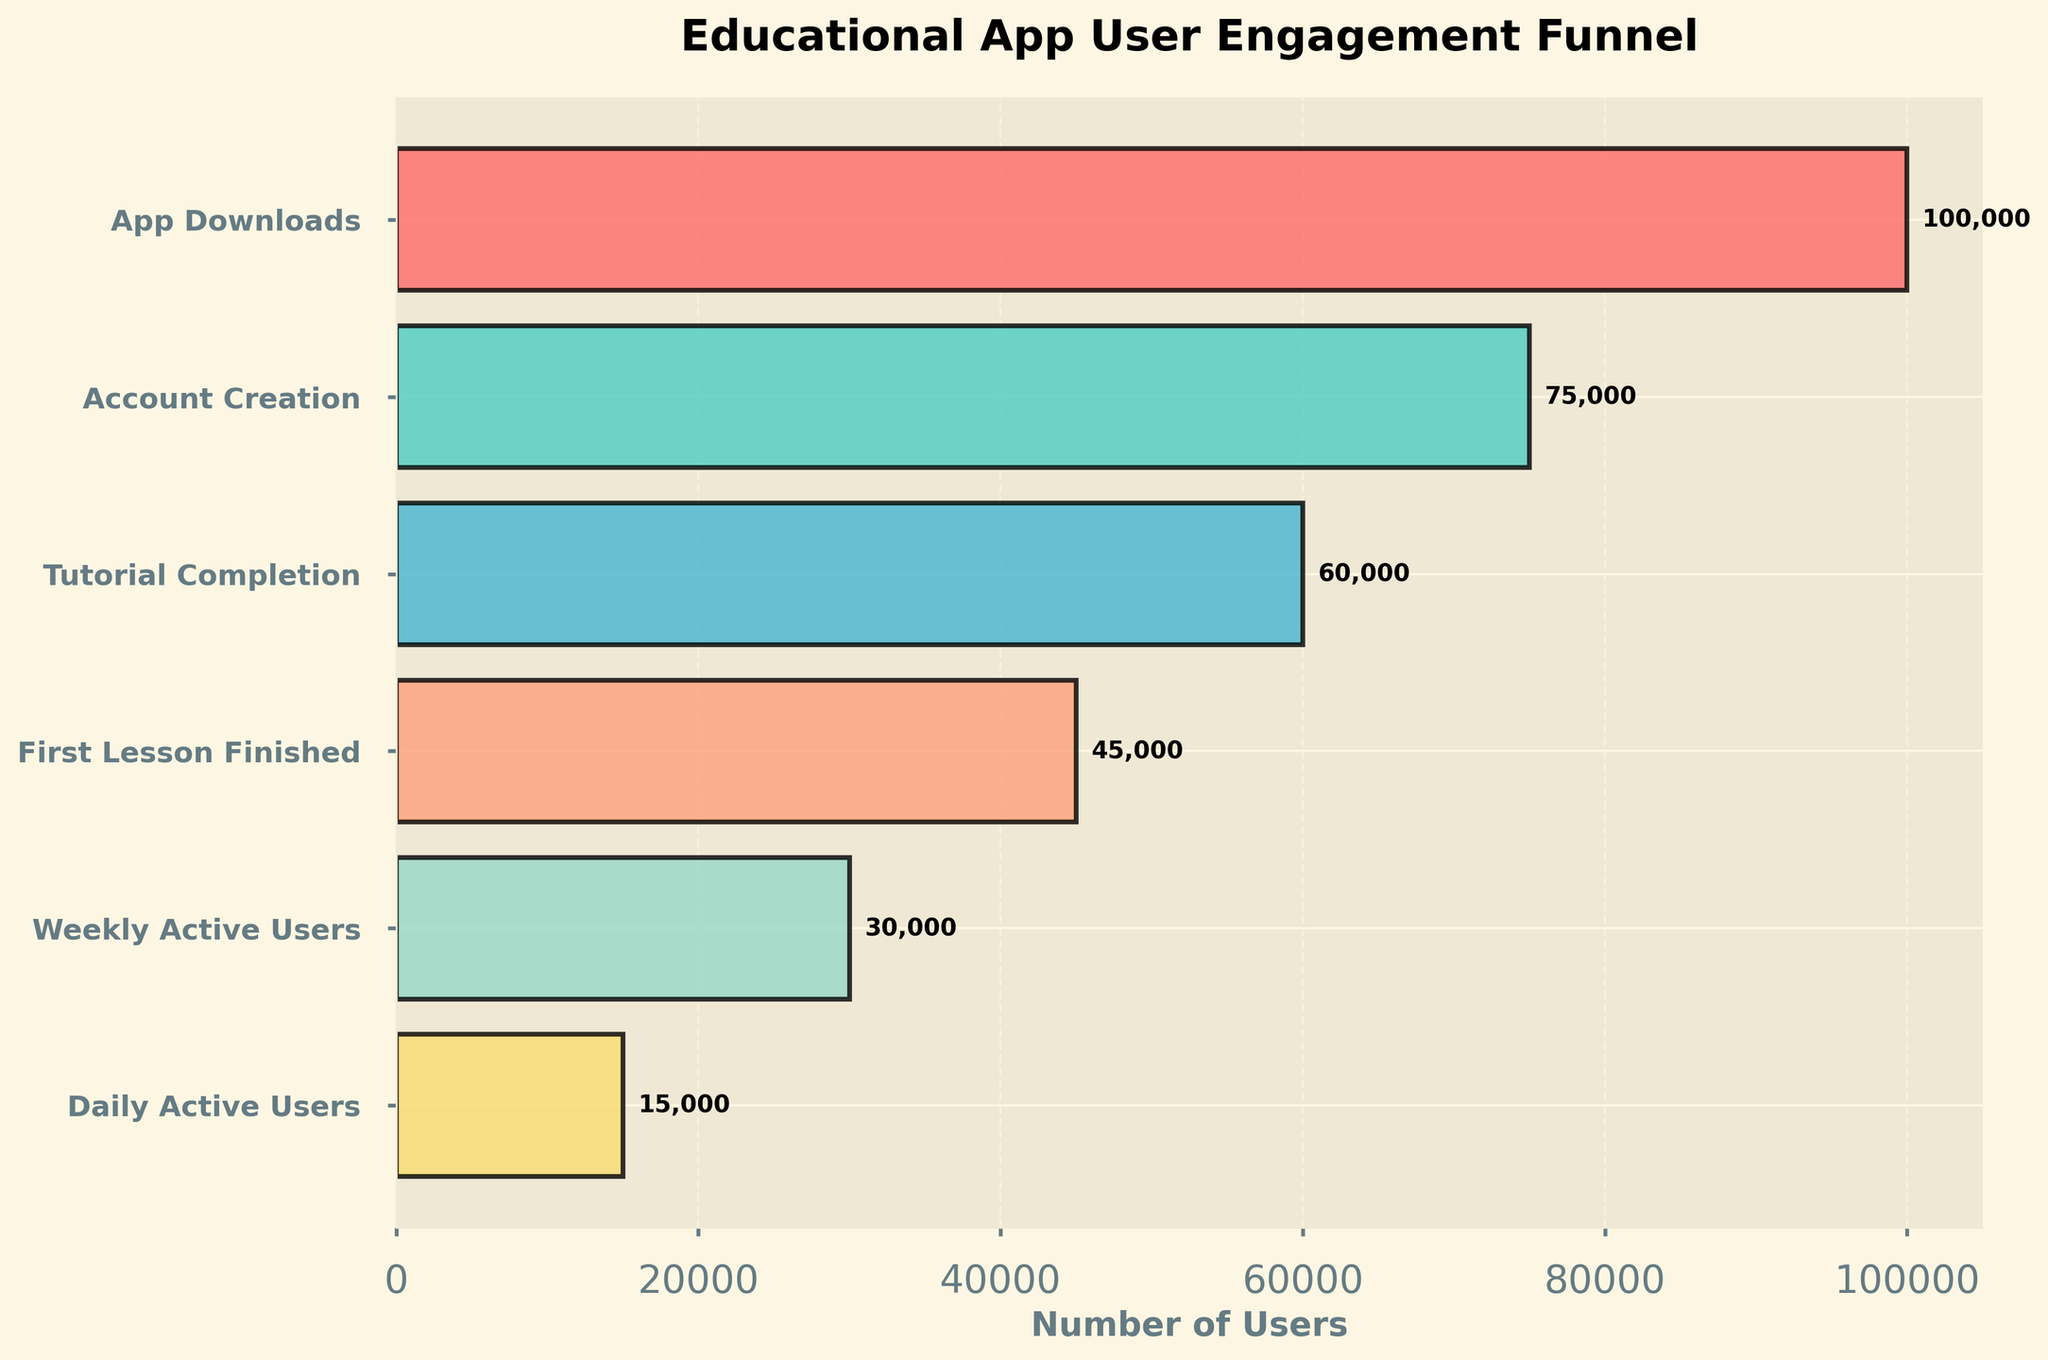What is the title of the funnel chart? The title of a chart is typically displayed at the top and gives an overall idea of what the chart represents. The title in this funnel chart is "Educational App User Engagement Funnel."
Answer: Educational App User Engagement Funnel How many stages are represented in the funnel chart? The funnel chart shows different stages of user engagement for the educational app. Counting these stages from top to bottom, there are six stages.
Answer: Six Which stage has the highest number of users? The number of users for each stage can be identified by examining the length of the bars. The longest bar, which represents the highest number of users, is for the "App Downloads" stage.
Answer: App Downloads What is the difference in user numbers between the "Account Creation" stage and the "Weekly Active Users" stage? To find the difference in user numbers between two stages, subtract the number of users in one stage from the number of users in the other stage. The "Account Creation" stage has 75,000 users, and the "Weekly Active Users" stage has 30,000 users. So, 75,000 - 30,000 = 45,000.
Answer: 45,000 What percentage of users progress from "App Downloads" to "Account Creation"? Calculate the percentage by dividing the number of users who created an account by the number of app downloads, then multiplying by 100. This is (75,000 / 100,000) * 100 = 75%.
Answer: 75% Which stage shows the most significant drop in user engagement? The most significant drop is observed by comparing the number of users between successive stages. The steepest decline is from the "First Lesson Finished" stage (45,000 users) to the "Weekly Active Users" stage (30,000 users), which is a drop of 15,000 users.
Answer: From First Lesson Finished to Weekly Active Users What is the average number of users across all stages? To find the average number of users, sum all user numbers and divide by the total number of stages. The sum is 100,000 + 75,000 + 60,000 + 45,000 + 30,000 + 15,000 = 325,000 users. Divide this by 6 stages to get the average: 325,000 / 6 = approximately 54,167 users.
Answer: Approximately 54,167 users How does the number of "Tutorial Completion" users compare to the "Daily Active Users"? The "Tutorial Completion" stage has 60,000 users, while the "Daily Active Users" stage has 15,000 users. Comparing these two numbers, 60,000 is greater than 15,000.
Answer: Tutorial Completion has more users Explain the trend that can be observed from "App Downloads" to "Daily Active Users"? The trend is a gradual decrease in the number of users as they progress through each stage. Starting from "App Downloads" with 100,000 users, the numbers decrease through "Account Creation" (75,000), "Tutorial Completion" (60,000), "First Lesson Finished" (45,000), "Weekly Active Users" (30,000), down to "Daily Active Users" (15,000).
Answer: Decreasing trend Which stage has half the number of users compared to the "Weekly Active Users" stage? To find out which stage has half the number of users compared to "Weekly Active Users" (30,000), we look for a stage with roughly 15,000 users. The "Daily Active Users" stage, which has 15,000 users, fits this criterion.
Answer: Daily Active Users 